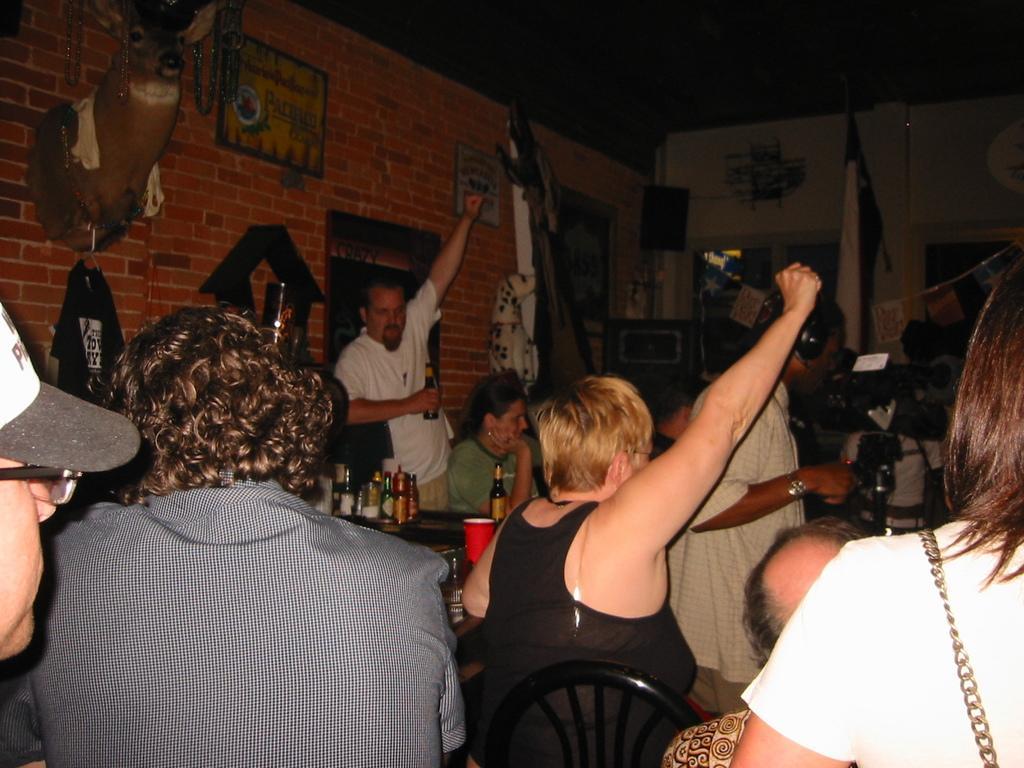Can you describe this image briefly? In this image there are a group of people sitting, and in the background there is a table. On the table there are some bottles and some of them are holding some bottles and one person is holding a camera, and wearing a headset. And in the background there are some objects, animal head, posters on the wall and at the top there is ceiling. 